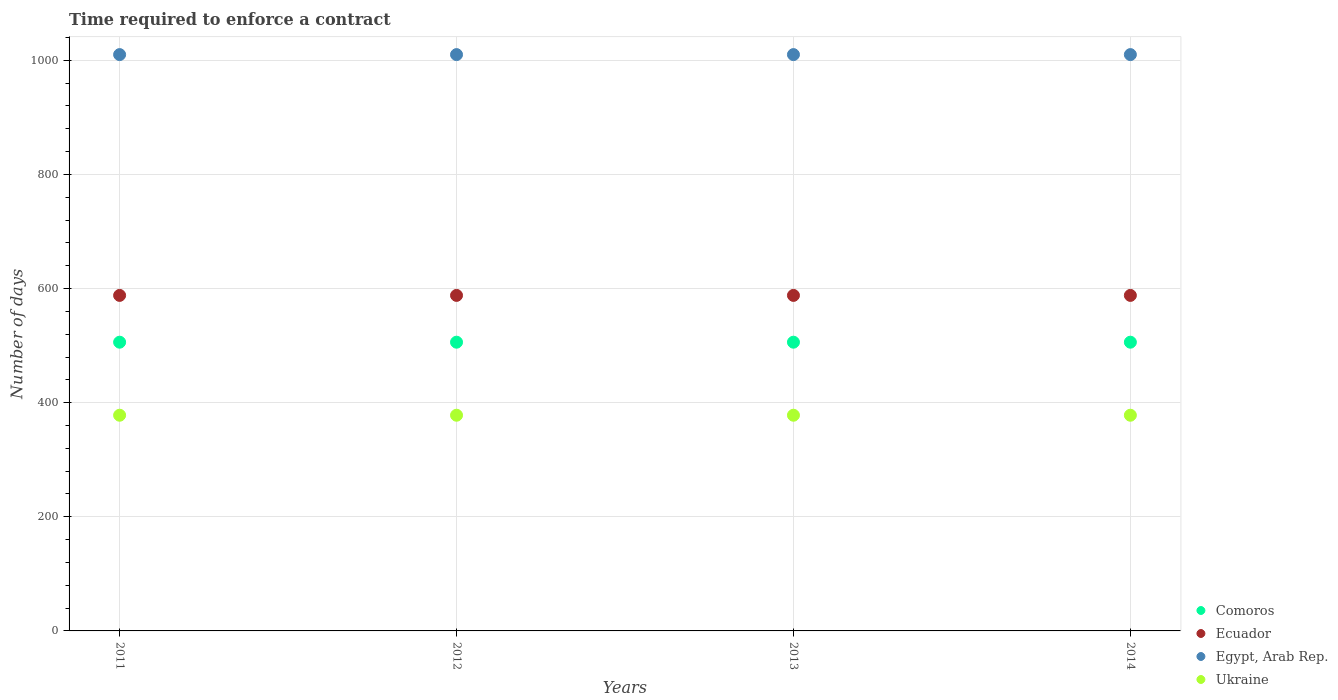How many different coloured dotlines are there?
Your answer should be very brief. 4. What is the number of days required to enforce a contract in Ukraine in 2012?
Keep it short and to the point. 378. Across all years, what is the maximum number of days required to enforce a contract in Ukraine?
Provide a succinct answer. 378. Across all years, what is the minimum number of days required to enforce a contract in Comoros?
Keep it short and to the point. 506. In which year was the number of days required to enforce a contract in Egypt, Arab Rep. maximum?
Ensure brevity in your answer.  2011. In which year was the number of days required to enforce a contract in Ukraine minimum?
Give a very brief answer. 2011. What is the total number of days required to enforce a contract in Ecuador in the graph?
Your answer should be compact. 2352. What is the difference between the number of days required to enforce a contract in Ecuador in 2011 and the number of days required to enforce a contract in Ukraine in 2013?
Offer a terse response. 210. What is the average number of days required to enforce a contract in Ecuador per year?
Give a very brief answer. 588. In the year 2011, what is the difference between the number of days required to enforce a contract in Egypt, Arab Rep. and number of days required to enforce a contract in Ecuador?
Your answer should be compact. 422. In how many years, is the number of days required to enforce a contract in Comoros greater than 40 days?
Make the answer very short. 4. Is the difference between the number of days required to enforce a contract in Egypt, Arab Rep. in 2012 and 2013 greater than the difference between the number of days required to enforce a contract in Ecuador in 2012 and 2013?
Keep it short and to the point. No. What is the difference between the highest and the second highest number of days required to enforce a contract in Ukraine?
Provide a short and direct response. 0. Is the sum of the number of days required to enforce a contract in Ecuador in 2011 and 2014 greater than the maximum number of days required to enforce a contract in Egypt, Arab Rep. across all years?
Give a very brief answer. Yes. Is it the case that in every year, the sum of the number of days required to enforce a contract in Comoros and number of days required to enforce a contract in Egypt, Arab Rep.  is greater than the sum of number of days required to enforce a contract in Ecuador and number of days required to enforce a contract in Ukraine?
Keep it short and to the point. Yes. Is it the case that in every year, the sum of the number of days required to enforce a contract in Comoros and number of days required to enforce a contract in Ukraine  is greater than the number of days required to enforce a contract in Egypt, Arab Rep.?
Provide a short and direct response. No. Does the number of days required to enforce a contract in Ukraine monotonically increase over the years?
Provide a short and direct response. No. How many legend labels are there?
Your answer should be compact. 4. How are the legend labels stacked?
Offer a terse response. Vertical. What is the title of the graph?
Make the answer very short. Time required to enforce a contract. Does "Trinidad and Tobago" appear as one of the legend labels in the graph?
Provide a short and direct response. No. What is the label or title of the X-axis?
Provide a succinct answer. Years. What is the label or title of the Y-axis?
Provide a short and direct response. Number of days. What is the Number of days of Comoros in 2011?
Give a very brief answer. 506. What is the Number of days of Ecuador in 2011?
Your answer should be very brief. 588. What is the Number of days in Egypt, Arab Rep. in 2011?
Give a very brief answer. 1010. What is the Number of days of Ukraine in 2011?
Offer a terse response. 378. What is the Number of days in Comoros in 2012?
Your response must be concise. 506. What is the Number of days in Ecuador in 2012?
Offer a very short reply. 588. What is the Number of days in Egypt, Arab Rep. in 2012?
Offer a very short reply. 1010. What is the Number of days of Ukraine in 2012?
Give a very brief answer. 378. What is the Number of days of Comoros in 2013?
Offer a terse response. 506. What is the Number of days of Ecuador in 2013?
Your response must be concise. 588. What is the Number of days in Egypt, Arab Rep. in 2013?
Your response must be concise. 1010. What is the Number of days in Ukraine in 2013?
Ensure brevity in your answer.  378. What is the Number of days of Comoros in 2014?
Give a very brief answer. 506. What is the Number of days in Ecuador in 2014?
Keep it short and to the point. 588. What is the Number of days in Egypt, Arab Rep. in 2014?
Keep it short and to the point. 1010. What is the Number of days of Ukraine in 2014?
Keep it short and to the point. 378. Across all years, what is the maximum Number of days of Comoros?
Provide a short and direct response. 506. Across all years, what is the maximum Number of days of Ecuador?
Provide a succinct answer. 588. Across all years, what is the maximum Number of days in Egypt, Arab Rep.?
Offer a very short reply. 1010. Across all years, what is the maximum Number of days in Ukraine?
Make the answer very short. 378. Across all years, what is the minimum Number of days of Comoros?
Provide a short and direct response. 506. Across all years, what is the minimum Number of days in Ecuador?
Keep it short and to the point. 588. Across all years, what is the minimum Number of days of Egypt, Arab Rep.?
Make the answer very short. 1010. Across all years, what is the minimum Number of days of Ukraine?
Provide a short and direct response. 378. What is the total Number of days of Comoros in the graph?
Provide a succinct answer. 2024. What is the total Number of days in Ecuador in the graph?
Provide a short and direct response. 2352. What is the total Number of days of Egypt, Arab Rep. in the graph?
Your response must be concise. 4040. What is the total Number of days of Ukraine in the graph?
Your answer should be very brief. 1512. What is the difference between the Number of days in Comoros in 2011 and that in 2012?
Provide a short and direct response. 0. What is the difference between the Number of days of Ukraine in 2011 and that in 2012?
Your answer should be very brief. 0. What is the difference between the Number of days in Ecuador in 2011 and that in 2013?
Your response must be concise. 0. What is the difference between the Number of days of Ukraine in 2011 and that in 2013?
Keep it short and to the point. 0. What is the difference between the Number of days in Comoros in 2011 and that in 2014?
Your answer should be very brief. 0. What is the difference between the Number of days in Egypt, Arab Rep. in 2011 and that in 2014?
Ensure brevity in your answer.  0. What is the difference between the Number of days in Ukraine in 2011 and that in 2014?
Ensure brevity in your answer.  0. What is the difference between the Number of days of Ecuador in 2012 and that in 2013?
Give a very brief answer. 0. What is the difference between the Number of days of Ukraine in 2012 and that in 2013?
Make the answer very short. 0. What is the difference between the Number of days of Comoros in 2012 and that in 2014?
Keep it short and to the point. 0. What is the difference between the Number of days of Egypt, Arab Rep. in 2012 and that in 2014?
Keep it short and to the point. 0. What is the difference between the Number of days in Ecuador in 2013 and that in 2014?
Provide a succinct answer. 0. What is the difference between the Number of days in Egypt, Arab Rep. in 2013 and that in 2014?
Offer a terse response. 0. What is the difference between the Number of days of Ukraine in 2013 and that in 2014?
Make the answer very short. 0. What is the difference between the Number of days in Comoros in 2011 and the Number of days in Ecuador in 2012?
Offer a terse response. -82. What is the difference between the Number of days in Comoros in 2011 and the Number of days in Egypt, Arab Rep. in 2012?
Keep it short and to the point. -504. What is the difference between the Number of days of Comoros in 2011 and the Number of days of Ukraine in 2012?
Offer a very short reply. 128. What is the difference between the Number of days in Ecuador in 2011 and the Number of days in Egypt, Arab Rep. in 2012?
Ensure brevity in your answer.  -422. What is the difference between the Number of days of Ecuador in 2011 and the Number of days of Ukraine in 2012?
Your answer should be very brief. 210. What is the difference between the Number of days in Egypt, Arab Rep. in 2011 and the Number of days in Ukraine in 2012?
Offer a terse response. 632. What is the difference between the Number of days of Comoros in 2011 and the Number of days of Ecuador in 2013?
Make the answer very short. -82. What is the difference between the Number of days in Comoros in 2011 and the Number of days in Egypt, Arab Rep. in 2013?
Ensure brevity in your answer.  -504. What is the difference between the Number of days in Comoros in 2011 and the Number of days in Ukraine in 2013?
Keep it short and to the point. 128. What is the difference between the Number of days in Ecuador in 2011 and the Number of days in Egypt, Arab Rep. in 2013?
Provide a short and direct response. -422. What is the difference between the Number of days of Ecuador in 2011 and the Number of days of Ukraine in 2013?
Give a very brief answer. 210. What is the difference between the Number of days of Egypt, Arab Rep. in 2011 and the Number of days of Ukraine in 2013?
Make the answer very short. 632. What is the difference between the Number of days in Comoros in 2011 and the Number of days in Ecuador in 2014?
Provide a short and direct response. -82. What is the difference between the Number of days of Comoros in 2011 and the Number of days of Egypt, Arab Rep. in 2014?
Provide a short and direct response. -504. What is the difference between the Number of days in Comoros in 2011 and the Number of days in Ukraine in 2014?
Provide a short and direct response. 128. What is the difference between the Number of days in Ecuador in 2011 and the Number of days in Egypt, Arab Rep. in 2014?
Offer a very short reply. -422. What is the difference between the Number of days of Ecuador in 2011 and the Number of days of Ukraine in 2014?
Your answer should be very brief. 210. What is the difference between the Number of days of Egypt, Arab Rep. in 2011 and the Number of days of Ukraine in 2014?
Ensure brevity in your answer.  632. What is the difference between the Number of days in Comoros in 2012 and the Number of days in Ecuador in 2013?
Ensure brevity in your answer.  -82. What is the difference between the Number of days of Comoros in 2012 and the Number of days of Egypt, Arab Rep. in 2013?
Your answer should be very brief. -504. What is the difference between the Number of days in Comoros in 2012 and the Number of days in Ukraine in 2013?
Give a very brief answer. 128. What is the difference between the Number of days in Ecuador in 2012 and the Number of days in Egypt, Arab Rep. in 2013?
Offer a terse response. -422. What is the difference between the Number of days in Ecuador in 2012 and the Number of days in Ukraine in 2013?
Your answer should be very brief. 210. What is the difference between the Number of days in Egypt, Arab Rep. in 2012 and the Number of days in Ukraine in 2013?
Your answer should be compact. 632. What is the difference between the Number of days of Comoros in 2012 and the Number of days of Ecuador in 2014?
Your answer should be compact. -82. What is the difference between the Number of days of Comoros in 2012 and the Number of days of Egypt, Arab Rep. in 2014?
Ensure brevity in your answer.  -504. What is the difference between the Number of days of Comoros in 2012 and the Number of days of Ukraine in 2014?
Provide a succinct answer. 128. What is the difference between the Number of days in Ecuador in 2012 and the Number of days in Egypt, Arab Rep. in 2014?
Offer a terse response. -422. What is the difference between the Number of days of Ecuador in 2012 and the Number of days of Ukraine in 2014?
Give a very brief answer. 210. What is the difference between the Number of days of Egypt, Arab Rep. in 2012 and the Number of days of Ukraine in 2014?
Offer a terse response. 632. What is the difference between the Number of days of Comoros in 2013 and the Number of days of Ecuador in 2014?
Your response must be concise. -82. What is the difference between the Number of days of Comoros in 2013 and the Number of days of Egypt, Arab Rep. in 2014?
Offer a very short reply. -504. What is the difference between the Number of days in Comoros in 2013 and the Number of days in Ukraine in 2014?
Give a very brief answer. 128. What is the difference between the Number of days of Ecuador in 2013 and the Number of days of Egypt, Arab Rep. in 2014?
Offer a very short reply. -422. What is the difference between the Number of days in Ecuador in 2013 and the Number of days in Ukraine in 2014?
Ensure brevity in your answer.  210. What is the difference between the Number of days of Egypt, Arab Rep. in 2013 and the Number of days of Ukraine in 2014?
Offer a terse response. 632. What is the average Number of days of Comoros per year?
Your answer should be compact. 506. What is the average Number of days in Ecuador per year?
Give a very brief answer. 588. What is the average Number of days in Egypt, Arab Rep. per year?
Ensure brevity in your answer.  1010. What is the average Number of days of Ukraine per year?
Make the answer very short. 378. In the year 2011, what is the difference between the Number of days of Comoros and Number of days of Ecuador?
Your answer should be compact. -82. In the year 2011, what is the difference between the Number of days in Comoros and Number of days in Egypt, Arab Rep.?
Give a very brief answer. -504. In the year 2011, what is the difference between the Number of days of Comoros and Number of days of Ukraine?
Give a very brief answer. 128. In the year 2011, what is the difference between the Number of days of Ecuador and Number of days of Egypt, Arab Rep.?
Keep it short and to the point. -422. In the year 2011, what is the difference between the Number of days of Ecuador and Number of days of Ukraine?
Your answer should be compact. 210. In the year 2011, what is the difference between the Number of days in Egypt, Arab Rep. and Number of days in Ukraine?
Offer a very short reply. 632. In the year 2012, what is the difference between the Number of days in Comoros and Number of days in Ecuador?
Make the answer very short. -82. In the year 2012, what is the difference between the Number of days of Comoros and Number of days of Egypt, Arab Rep.?
Your answer should be compact. -504. In the year 2012, what is the difference between the Number of days of Comoros and Number of days of Ukraine?
Provide a short and direct response. 128. In the year 2012, what is the difference between the Number of days in Ecuador and Number of days in Egypt, Arab Rep.?
Ensure brevity in your answer.  -422. In the year 2012, what is the difference between the Number of days in Ecuador and Number of days in Ukraine?
Your answer should be compact. 210. In the year 2012, what is the difference between the Number of days in Egypt, Arab Rep. and Number of days in Ukraine?
Your response must be concise. 632. In the year 2013, what is the difference between the Number of days of Comoros and Number of days of Ecuador?
Your answer should be compact. -82. In the year 2013, what is the difference between the Number of days in Comoros and Number of days in Egypt, Arab Rep.?
Your answer should be compact. -504. In the year 2013, what is the difference between the Number of days of Comoros and Number of days of Ukraine?
Keep it short and to the point. 128. In the year 2013, what is the difference between the Number of days of Ecuador and Number of days of Egypt, Arab Rep.?
Provide a succinct answer. -422. In the year 2013, what is the difference between the Number of days of Ecuador and Number of days of Ukraine?
Your response must be concise. 210. In the year 2013, what is the difference between the Number of days of Egypt, Arab Rep. and Number of days of Ukraine?
Offer a very short reply. 632. In the year 2014, what is the difference between the Number of days of Comoros and Number of days of Ecuador?
Your response must be concise. -82. In the year 2014, what is the difference between the Number of days of Comoros and Number of days of Egypt, Arab Rep.?
Keep it short and to the point. -504. In the year 2014, what is the difference between the Number of days of Comoros and Number of days of Ukraine?
Keep it short and to the point. 128. In the year 2014, what is the difference between the Number of days in Ecuador and Number of days in Egypt, Arab Rep.?
Make the answer very short. -422. In the year 2014, what is the difference between the Number of days of Ecuador and Number of days of Ukraine?
Your response must be concise. 210. In the year 2014, what is the difference between the Number of days in Egypt, Arab Rep. and Number of days in Ukraine?
Give a very brief answer. 632. What is the ratio of the Number of days in Egypt, Arab Rep. in 2011 to that in 2012?
Ensure brevity in your answer.  1. What is the ratio of the Number of days in Ukraine in 2011 to that in 2012?
Your response must be concise. 1. What is the ratio of the Number of days of Comoros in 2011 to that in 2013?
Provide a succinct answer. 1. What is the ratio of the Number of days of Ukraine in 2011 to that in 2013?
Provide a short and direct response. 1. What is the ratio of the Number of days in Ukraine in 2011 to that in 2014?
Your answer should be compact. 1. What is the ratio of the Number of days of Egypt, Arab Rep. in 2012 to that in 2013?
Provide a short and direct response. 1. What is the ratio of the Number of days of Comoros in 2012 to that in 2014?
Ensure brevity in your answer.  1. What is the ratio of the Number of days in Ecuador in 2012 to that in 2014?
Keep it short and to the point. 1. What is the ratio of the Number of days of Egypt, Arab Rep. in 2012 to that in 2014?
Offer a terse response. 1. What is the ratio of the Number of days in Ukraine in 2013 to that in 2014?
Offer a very short reply. 1. What is the difference between the highest and the second highest Number of days in Comoros?
Ensure brevity in your answer.  0. What is the difference between the highest and the second highest Number of days of Egypt, Arab Rep.?
Make the answer very short. 0. What is the difference between the highest and the second highest Number of days of Ukraine?
Offer a terse response. 0. What is the difference between the highest and the lowest Number of days of Ecuador?
Your answer should be very brief. 0. 